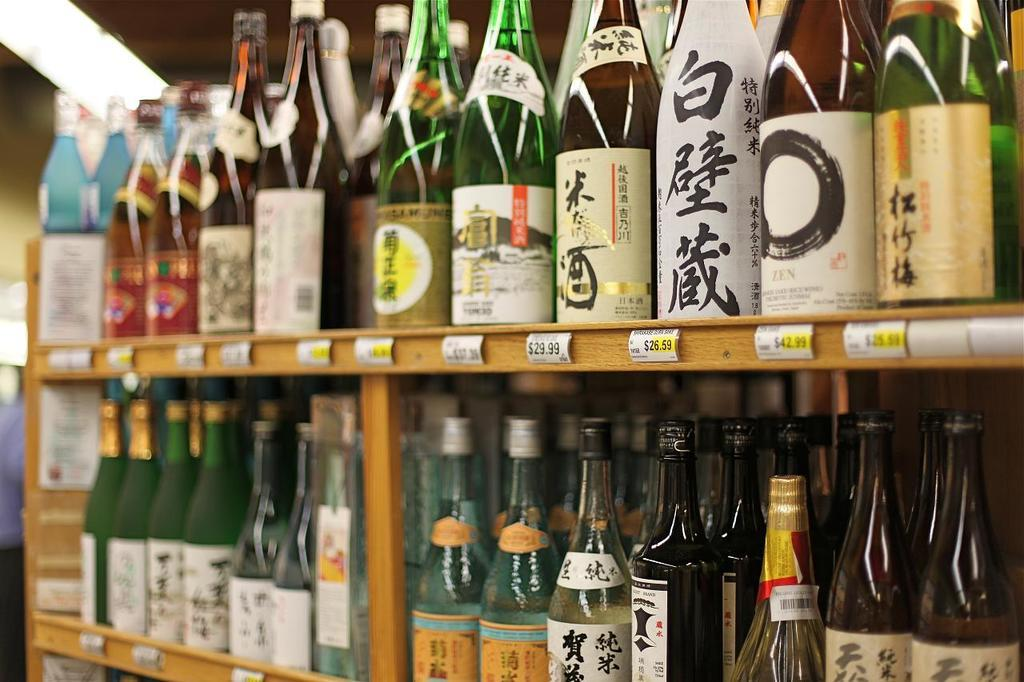What is the main object in the image? There is a rack in the image. What is on the rack? The rack is filled with bottles. How are the bottles arranged on the rack? The bottles are arranged in a sequence manner. What type of silver hydrant can be seen next to the plane in the image? There is no silver hydrant or plane present in the image; it only features a rack filled with bottles arranged in a sequence manner. 